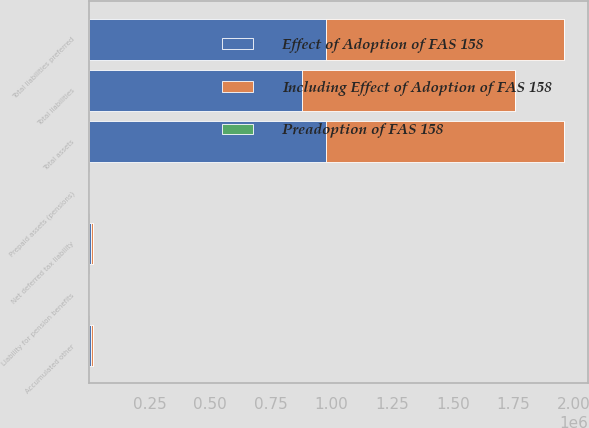Convert chart to OTSL. <chart><loc_0><loc_0><loc_500><loc_500><stacked_bar_chart><ecel><fcel>Prepaid assets (pensions)<fcel>Total assets<fcel>Liability for pension benefits<fcel>Net deferred tax liability<fcel>Total liabilities<fcel>Accumulated other<fcel>Total liabilities preferred<nl><fcel>Including Effect of Adoption of FAS 158<fcel>550<fcel>979952<fcel>1140<fcel>9088<fcel>877552<fcel>9642<fcel>979952<nl><fcel>Preadoption of FAS 158<fcel>532<fcel>538<fcel>230<fcel>236<fcel>6<fcel>532<fcel>538<nl><fcel>Effect of Adoption of FAS 158<fcel>18<fcel>979414<fcel>1370<fcel>8852<fcel>877546<fcel>9110<fcel>979414<nl></chart> 